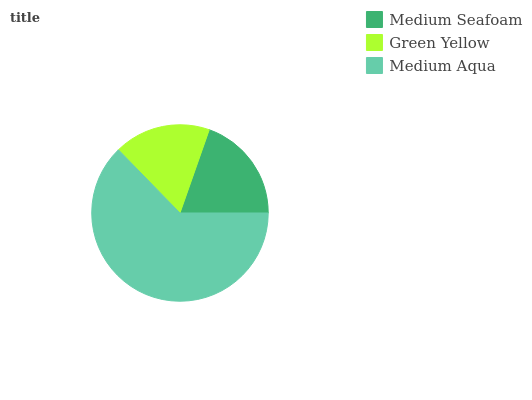Is Green Yellow the minimum?
Answer yes or no. Yes. Is Medium Aqua the maximum?
Answer yes or no. Yes. Is Medium Aqua the minimum?
Answer yes or no. No. Is Green Yellow the maximum?
Answer yes or no. No. Is Medium Aqua greater than Green Yellow?
Answer yes or no. Yes. Is Green Yellow less than Medium Aqua?
Answer yes or no. Yes. Is Green Yellow greater than Medium Aqua?
Answer yes or no. No. Is Medium Aqua less than Green Yellow?
Answer yes or no. No. Is Medium Seafoam the high median?
Answer yes or no. Yes. Is Medium Seafoam the low median?
Answer yes or no. Yes. Is Green Yellow the high median?
Answer yes or no. No. Is Green Yellow the low median?
Answer yes or no. No. 